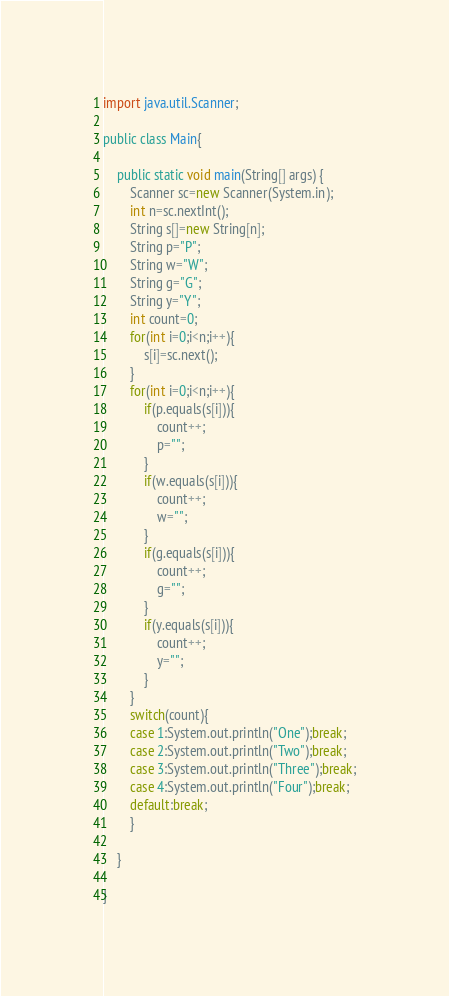<code> <loc_0><loc_0><loc_500><loc_500><_Java_>import java.util.Scanner;

public class Main{

	public static void main(String[] args) {
		Scanner sc=new Scanner(System.in);
		int n=sc.nextInt();
		String s[]=new String[n];
		String p="P";
		String w="W";
		String g="G";
		String y="Y";
		int count=0;
		for(int i=0;i<n;i++){
			s[i]=sc.next();
		}
		for(int i=0;i<n;i++){
			if(p.equals(s[i])){
				count++;
				p="";
			}
			if(w.equals(s[i])){
				count++;
				w="";
			}
			if(g.equals(s[i])){
				count++;
				g="";
			}
			if(y.equals(s[i])){
				count++;
				y="";
			}
		}
		switch(count){
		case 1:System.out.println("One");break;
		case 2:System.out.println("Two");break;
		case 3:System.out.println("Three");break;
		case 4:System.out.println("Four");break;
		default:break;
		}
		
	}

}</code> 